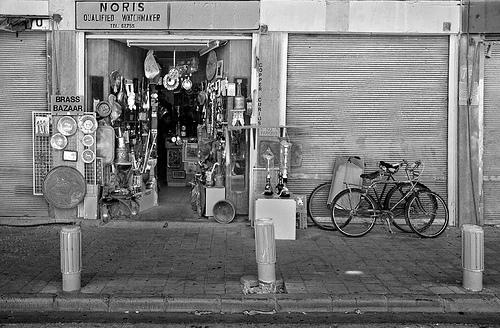Where are the bikes?
Concise answer only. Right side. Is this a mechanic shop?
Quick response, please. Yes. How many bikes?
Short answer required. 2. 